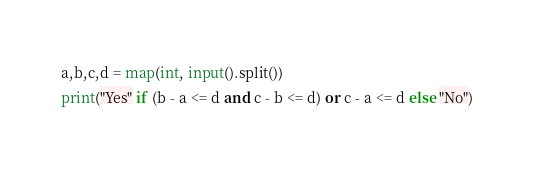Convert code to text. <code><loc_0><loc_0><loc_500><loc_500><_Python_>a,b,c,d = map(int, input().split())
print("Yes" if (b - a <= d and c - b <= d) or c - a <= d else "No")</code> 